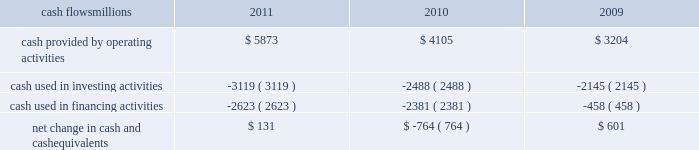Liquidity and capital resources as of december 31 , 2011 , our principal sources of liquidity included cash , cash equivalents , our receivables securitization facility , and our revolving credit facility , as well as the availability of commercial paper and other sources of financing through the capital markets .
We had $ 1.8 billion of committed credit available under our credit facility , with no borrowings outstanding as of december 31 , 2011 .
We did not make any borrowings under this facility during 2011 .
The value of the outstanding undivided interest held by investors under the receivables securitization facility was $ 100 million as of december 31 , 2011 , and is included in our consolidated statements of financial position as debt due after one year .
The receivables securitization facility obligates us to maintain an investment grade bond rating .
If our bond rating were to deteriorate , it could have an adverse impact on our liquidity .
Access to commercial paper as well as other capital market financings is dependent on market conditions .
Deterioration of our operating results or financial condition due to internal or external factors could negatively impact our ability to access capital markets as a source of liquidity .
Access to liquidity through the capital markets is also dependent on our financial stability .
We expect that we will continue to have access to liquidity by issuing bonds to public or private investors based on our assessment of the current condition of the credit markets .
At december 31 , 2011 and 2010 , we had a working capital surplus .
This reflects a strong cash position , which provides enhanced liquidity in an uncertain economic environment .
In addition , we believe we have adequate access to capital markets to meet cash requirements , and we have sufficient financial capacity to satisfy our current liabilities .
Cash flows millions 2011 2010 2009 .
Operating activities higher net income and lower cash income tax payments in 2011 increased cash provided by operating activities compared to 2010 .
The tax relief , unemployment insurance reauthorization , and job creation act of 2010 , enacted in december 2010 , provided for 100% ( 100 % ) bonus depreciation for qualified investments made during 2011 , and 50% ( 50 % ) bonus depreciation for qualified investments made during 2012 .
As a result of the act , the company deferred a substantial portion of its 2011 income tax expense .
This deferral decreased 2011 income tax payments , thereby contributing to the positive operating cash flow .
In future years , however , additional cash will be used to pay income taxes that were previously deferred .
In addition , the adoption of a new accounting standard in january of 2010 changed the accounting treatment for our receivables securitization facility from a sale of undivided interests ( recorded as an operating activity ) to a secured borrowing ( recorded as a financing activity ) , which decreased cash provided by operating activities by $ 400 million in 2010 .
Higher net income in 2010 increased cash provided by operating activities compared to 2009 .
Investing activities higher capital investments partially offset by higher proceeds from asset sales in 2011 drove the increase in cash used in investing activities compared to 2010 .
Higher capital investments and lower proceeds from asset sales in 2010 drove the increase in cash used in investing activities compared to 2009. .
What would operating cash flow have been in 2010 without the changed accounting standards for the receivables securitization facility , in us$ million? 
Computations: (4105 + 400)
Answer: 4505.0. Liquidity and capital resources as of december 31 , 2011 , our principal sources of liquidity included cash , cash equivalents , our receivables securitization facility , and our revolving credit facility , as well as the availability of commercial paper and other sources of financing through the capital markets .
We had $ 1.8 billion of committed credit available under our credit facility , with no borrowings outstanding as of december 31 , 2011 .
We did not make any borrowings under this facility during 2011 .
The value of the outstanding undivided interest held by investors under the receivables securitization facility was $ 100 million as of december 31 , 2011 , and is included in our consolidated statements of financial position as debt due after one year .
The receivables securitization facility obligates us to maintain an investment grade bond rating .
If our bond rating were to deteriorate , it could have an adverse impact on our liquidity .
Access to commercial paper as well as other capital market financings is dependent on market conditions .
Deterioration of our operating results or financial condition due to internal or external factors could negatively impact our ability to access capital markets as a source of liquidity .
Access to liquidity through the capital markets is also dependent on our financial stability .
We expect that we will continue to have access to liquidity by issuing bonds to public or private investors based on our assessment of the current condition of the credit markets .
At december 31 , 2011 and 2010 , we had a working capital surplus .
This reflects a strong cash position , which provides enhanced liquidity in an uncertain economic environment .
In addition , we believe we have adequate access to capital markets to meet cash requirements , and we have sufficient financial capacity to satisfy our current liabilities .
Cash flows millions 2011 2010 2009 .
Operating activities higher net income and lower cash income tax payments in 2011 increased cash provided by operating activities compared to 2010 .
The tax relief , unemployment insurance reauthorization , and job creation act of 2010 , enacted in december 2010 , provided for 100% ( 100 % ) bonus depreciation for qualified investments made during 2011 , and 50% ( 50 % ) bonus depreciation for qualified investments made during 2012 .
As a result of the act , the company deferred a substantial portion of its 2011 income tax expense .
This deferral decreased 2011 income tax payments , thereby contributing to the positive operating cash flow .
In future years , however , additional cash will be used to pay income taxes that were previously deferred .
In addition , the adoption of a new accounting standard in january of 2010 changed the accounting treatment for our receivables securitization facility from a sale of undivided interests ( recorded as an operating activity ) to a secured borrowing ( recorded as a financing activity ) , which decreased cash provided by operating activities by $ 400 million in 2010 .
Higher net income in 2010 increased cash provided by operating activities compared to 2009 .
Investing activities higher capital investments partially offset by higher proceeds from asset sales in 2011 drove the increase in cash used in investing activities compared to 2010 .
Higher capital investments and lower proceeds from asset sales in 2010 drove the increase in cash used in investing activities compared to 2009. .
What was the change in cash provided by operating activities from 2010 to 2011 , in millions? 
Computations: (5873 - 4105)
Answer: 1768.0. 